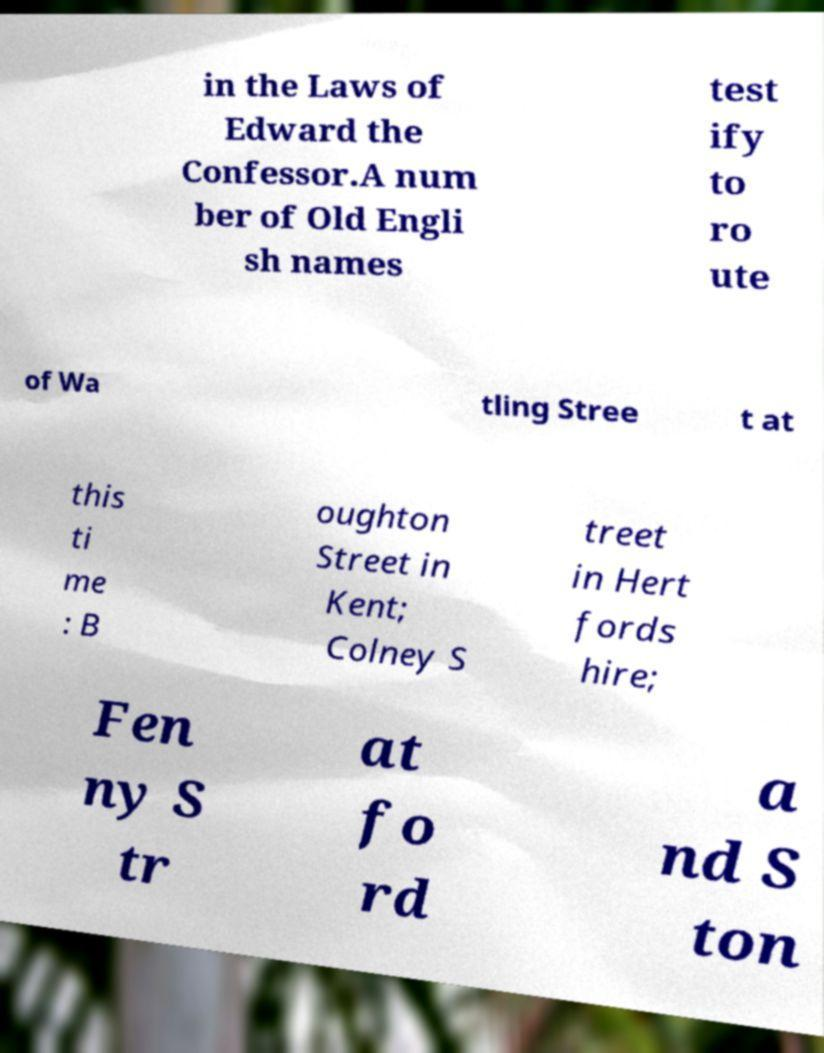I need the written content from this picture converted into text. Can you do that? in the Laws of Edward the Confessor.A num ber of Old Engli sh names test ify to ro ute of Wa tling Stree t at this ti me : B oughton Street in Kent; Colney S treet in Hert fords hire; Fen ny S tr at fo rd a nd S ton 